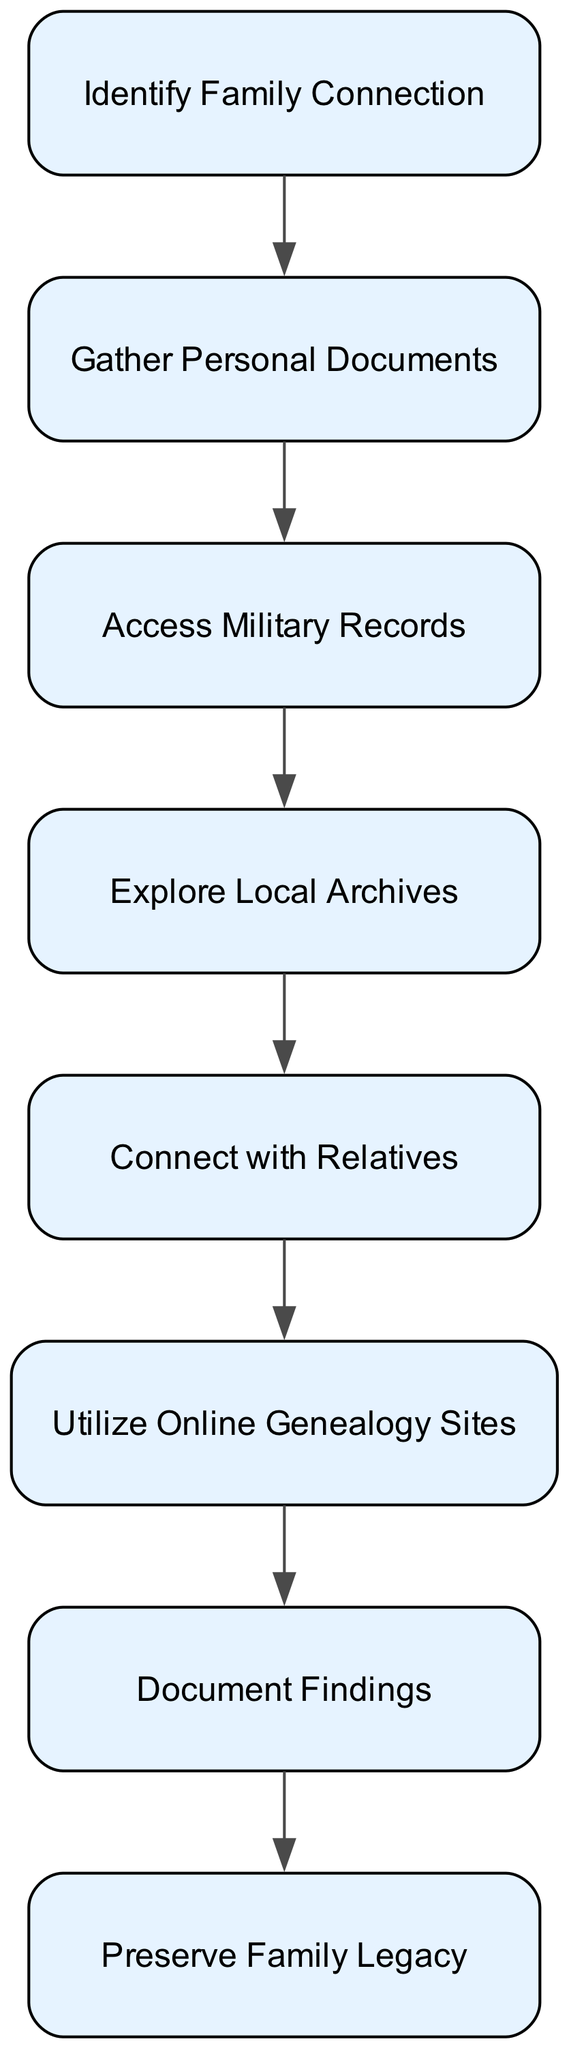What is the first step in the family history research process? The flow chart indicates that the first step is "Identify Family Connection", which sets the foundation for gathering information about the WWI soldier.
Answer: Identify Family Connection How many nodes are there in the flow chart? By counting the nodes representing distinct steps in the diagram, there are eight nodes total in the family history research process.
Answer: 8 What step comes after gathering personal documents? The diagram flows from "Gather Personal Documents" to "Access Military Records", indicating that after personal documents are gathered, the next step is accessing military records.
Answer: Access Military Records What is the final step in the flow chart? The flow chart ends with "Preserve Family Legacy", showing that the last action in the research process is about sharing the family history created.
Answer: Preserve Family Legacy Which step involves reaching out to family members? The step titled "Connect with Relatives" explicitly mentions contacting family members for shared stories and insights, indicating the importance of familial connections in this process.
Answer: Connect with Relatives What is the relationship between accessing military records and exploring local archives? The flow chart outlines a sequence where "Access Military Records" leads to "Explore Local Archives", showing that after accessing military records, one should explore local archives for further information.
Answer: Access Military Records → Explore Local Archives What action follows exploring local archives? After "Explore Local Archives", the subsequent action outlined is "Connect with Relatives", indicating the need to engage with family members for additional insights after exploring local records.
Answer: Connect with Relatives Which node in the flow chart has the purpose of organizing the gathered information? The node "Document Findings" is dedicated to compiling and organizing the gathered information into a structured format, specifically a family tree.
Answer: Document Findings What two steps are related to using technology in the research process? The two steps that relate to using technology are "Utilize Online Genealogy Sites" and "Document Findings", as they involve leveraging online tools for research and organizing the information collected.
Answer: Utilize Online Genealogy Sites, Document Findings 